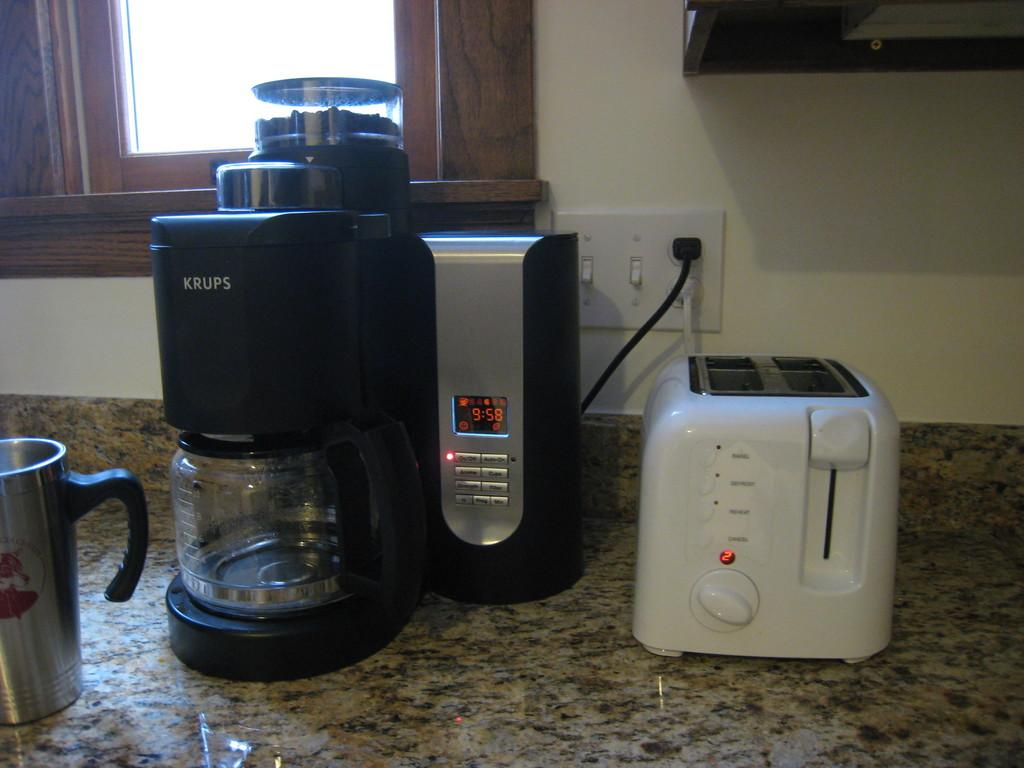What type of opening can be seen in the image? There is a window in the image. What type of structure is present in the image? There is a wall in the image. What device is used to control electrical appliances in the image? There is a socket switch board in the image. What kitchen appliance is present in the image? There is a bread toaster in the image. What type of appliance is used for mixing juices in the image? There is a digital juice mixer in the image. What type of container is present in the image? There is a jar in the image. What type of drinking vessel is present in the image? There is a cup in the image. Where are these objects located in the image? These objects are on a kitchen platform. What type of root is growing out of the bread toaster in the image? There is no root growing out of the bread toaster in the image; it is a kitchen appliance used for toasting bread. What story is being told by the digital juice mixer in the image? The digital juice mixer is an appliance used for mixing juices and does not tell a story in the image. 